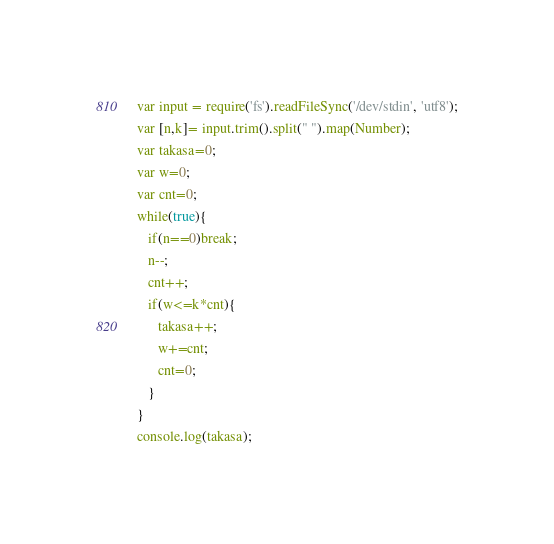Convert code to text. <code><loc_0><loc_0><loc_500><loc_500><_JavaScript_>var input = require('fs').readFileSync('/dev/stdin', 'utf8');
var [n,k]= input.trim().split(" ").map(Number);
var takasa=0;
var w=0;
var cnt=0;
while(true){
   if(n==0)break;
   n--;
   cnt++;
   if(w<=k*cnt){
      takasa++;
      w+=cnt;
      cnt=0;
   }
}
console.log(takasa);
</code> 